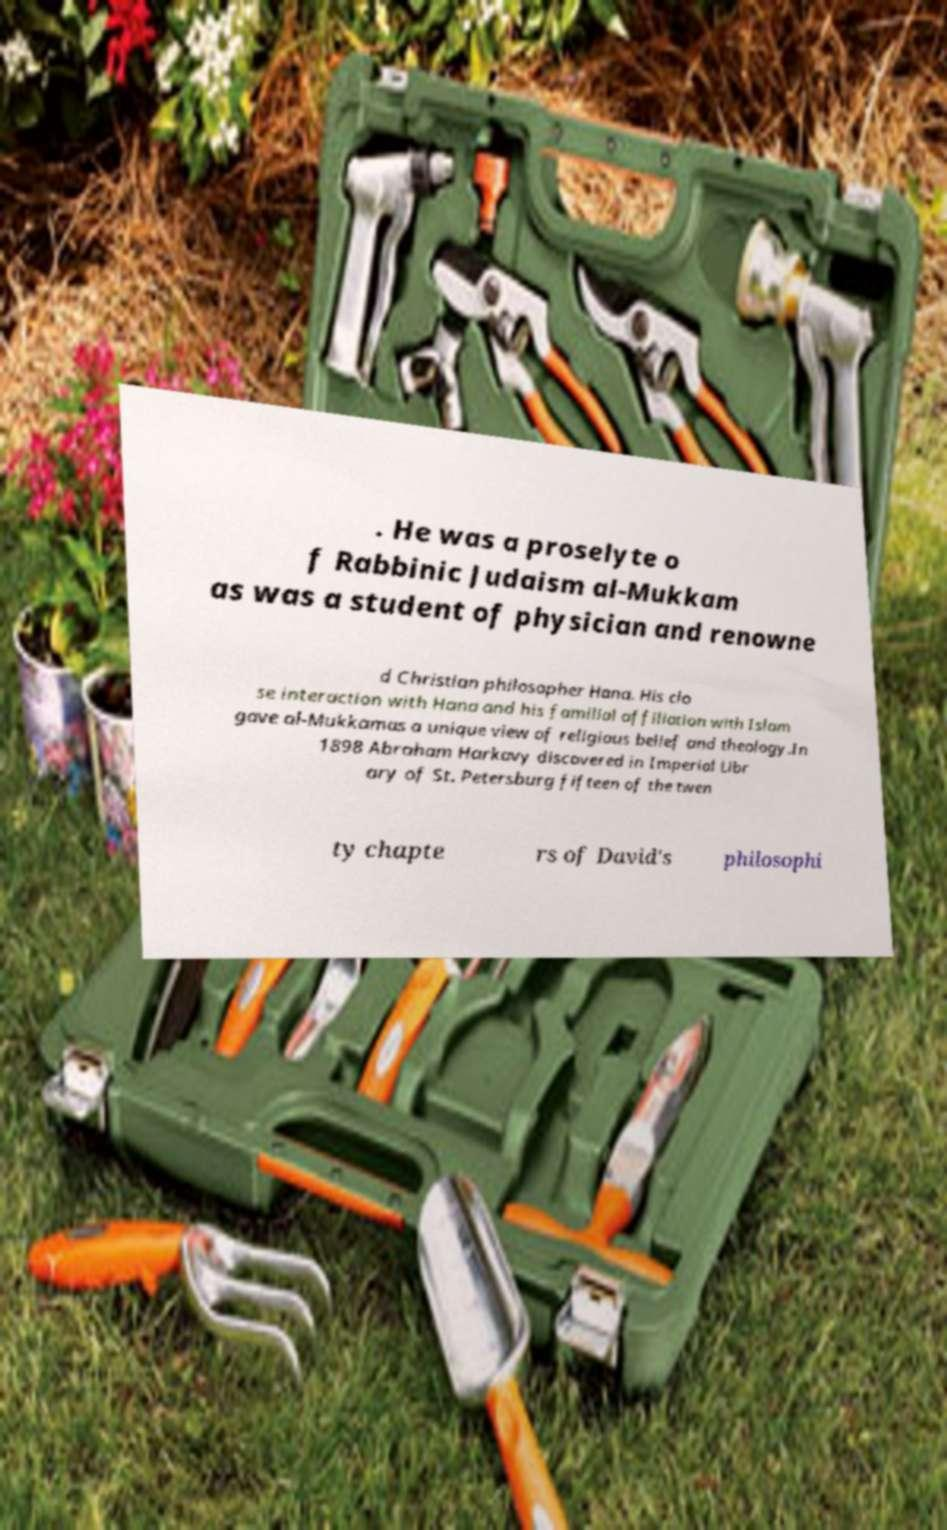Can you accurately transcribe the text from the provided image for me? . He was a proselyte o f Rabbinic Judaism al-Mukkam as was a student of physician and renowne d Christian philosopher Hana. His clo se interaction with Hana and his familial affiliation with Islam gave al-Mukkamas a unique view of religious belief and theology.In 1898 Abraham Harkavy discovered in Imperial Libr ary of St. Petersburg fifteen of the twen ty chapte rs of David's philosophi 